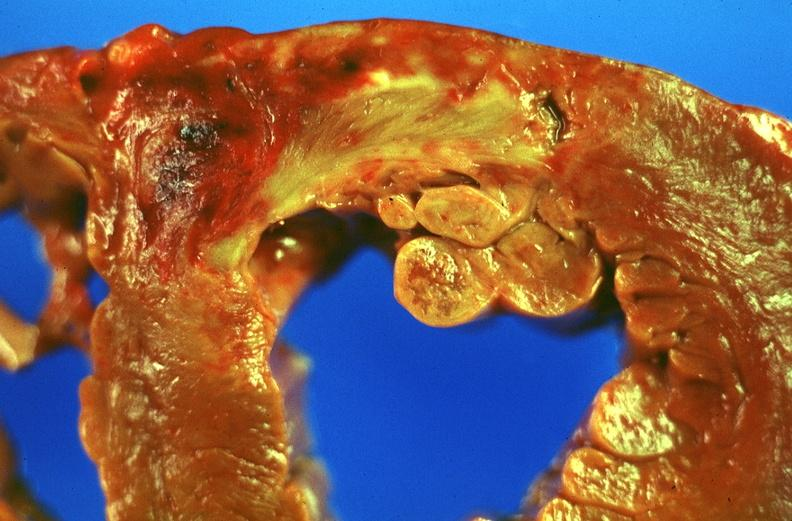s chest and abdomen slide present?
Answer the question using a single word or phrase. No 